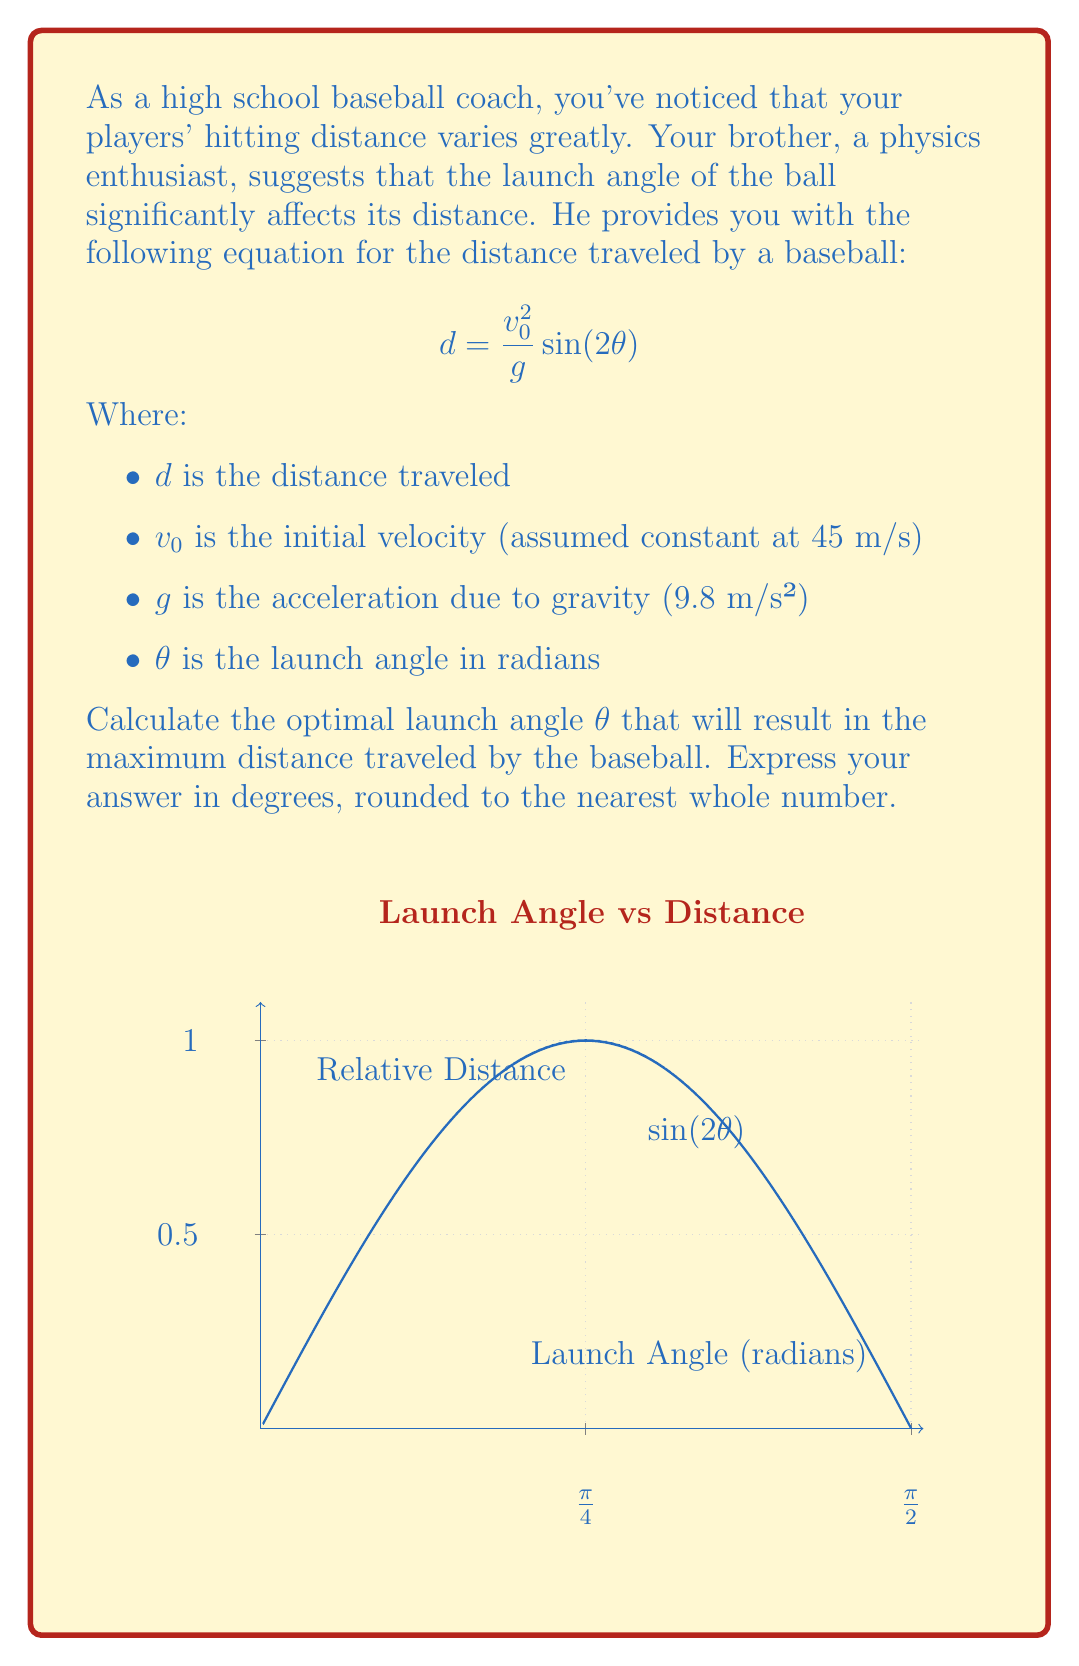Show me your answer to this math problem. To find the optimal launch angle, we need to maximize the function $d(\theta) = \frac{v_0^2}{g} \sin(2\theta)$. Since $\frac{v_0^2}{g}$ is constant, we only need to maximize $\sin(2\theta)$.

Step 1: The maximum value of sine is 1, which occurs when its argument is $\frac{\pi}{2}$ radians or 90°.

Step 2: Set up the equation:
$$2\theta = \frac{\pi}{2}$$

Step 3: Solve for $\theta$:
$$\theta = \frac{\pi}{4}$$

Step 4: Convert radians to degrees:
$$\theta = \frac{\pi}{4} \cdot \frac{180°}{\pi} = 45°$$

Therefore, the optimal launch angle for maximum distance is 45°.

Note: This result assumes no air resistance. In real-world conditions, the optimal angle might be slightly lower due to air resistance.
Answer: 45° 